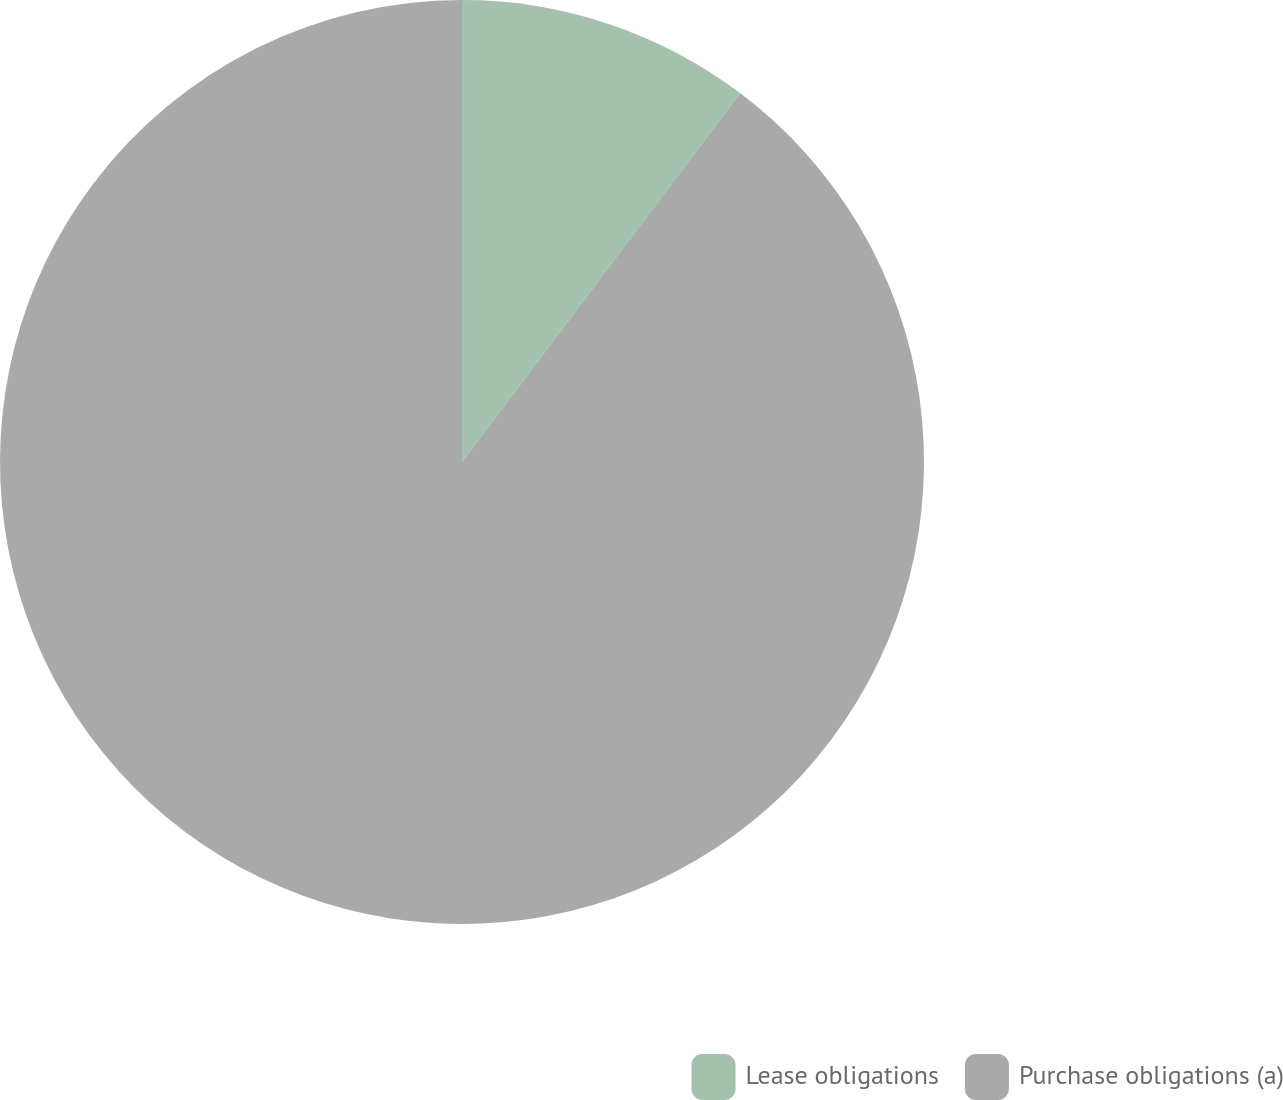Convert chart. <chart><loc_0><loc_0><loc_500><loc_500><pie_chart><fcel>Lease obligations<fcel>Purchase obligations (a)<nl><fcel>10.28%<fcel>89.72%<nl></chart> 